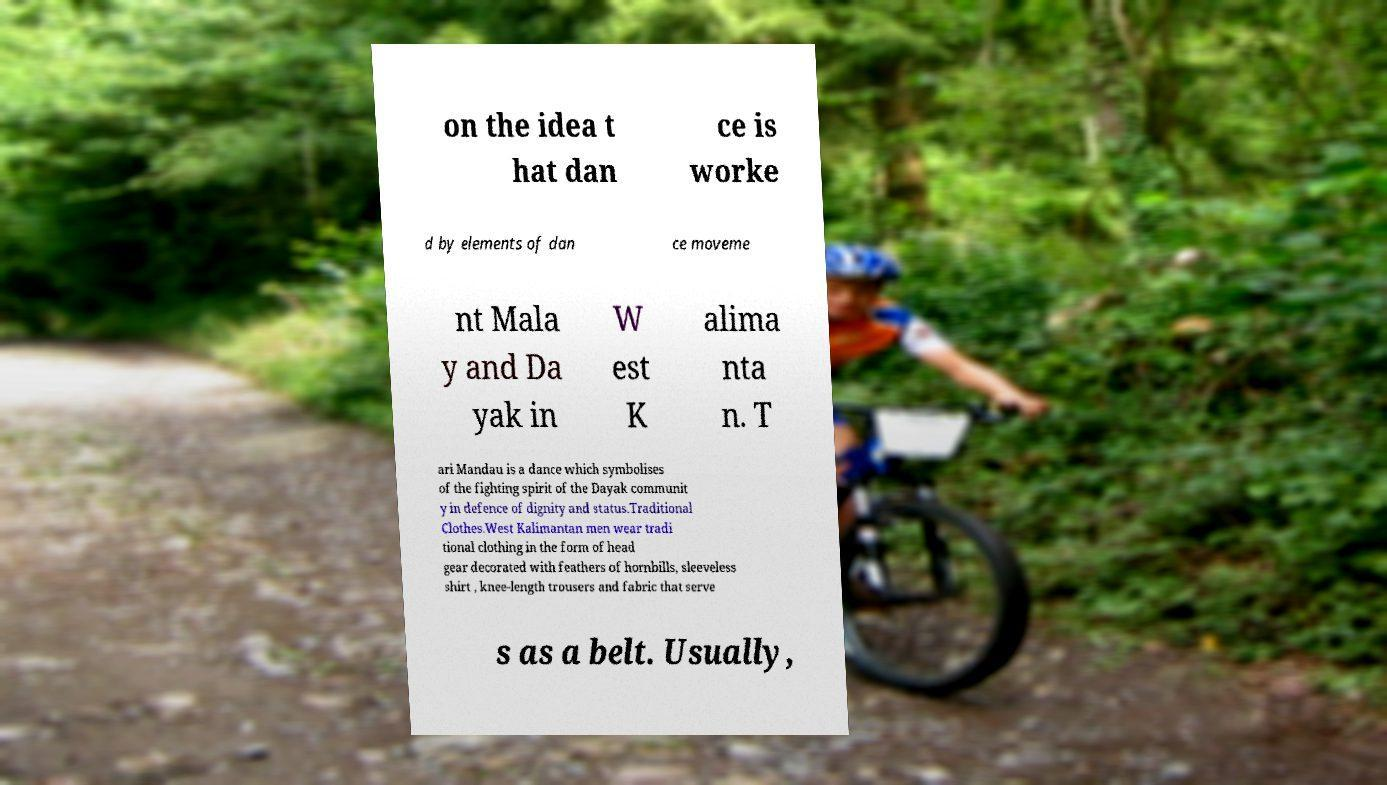There's text embedded in this image that I need extracted. Can you transcribe it verbatim? on the idea t hat dan ce is worke d by elements of dan ce moveme nt Mala y and Da yak in W est K alima nta n. T ari Mandau is a dance which symbolises of the fighting spirit of the Dayak communit y in defence of dignity and status.Traditional Clothes.West Kalimantan men wear tradi tional clothing in the form of head gear decorated with feathers of hornbills, sleeveless shirt , knee-length trousers and fabric that serve s as a belt. Usually, 